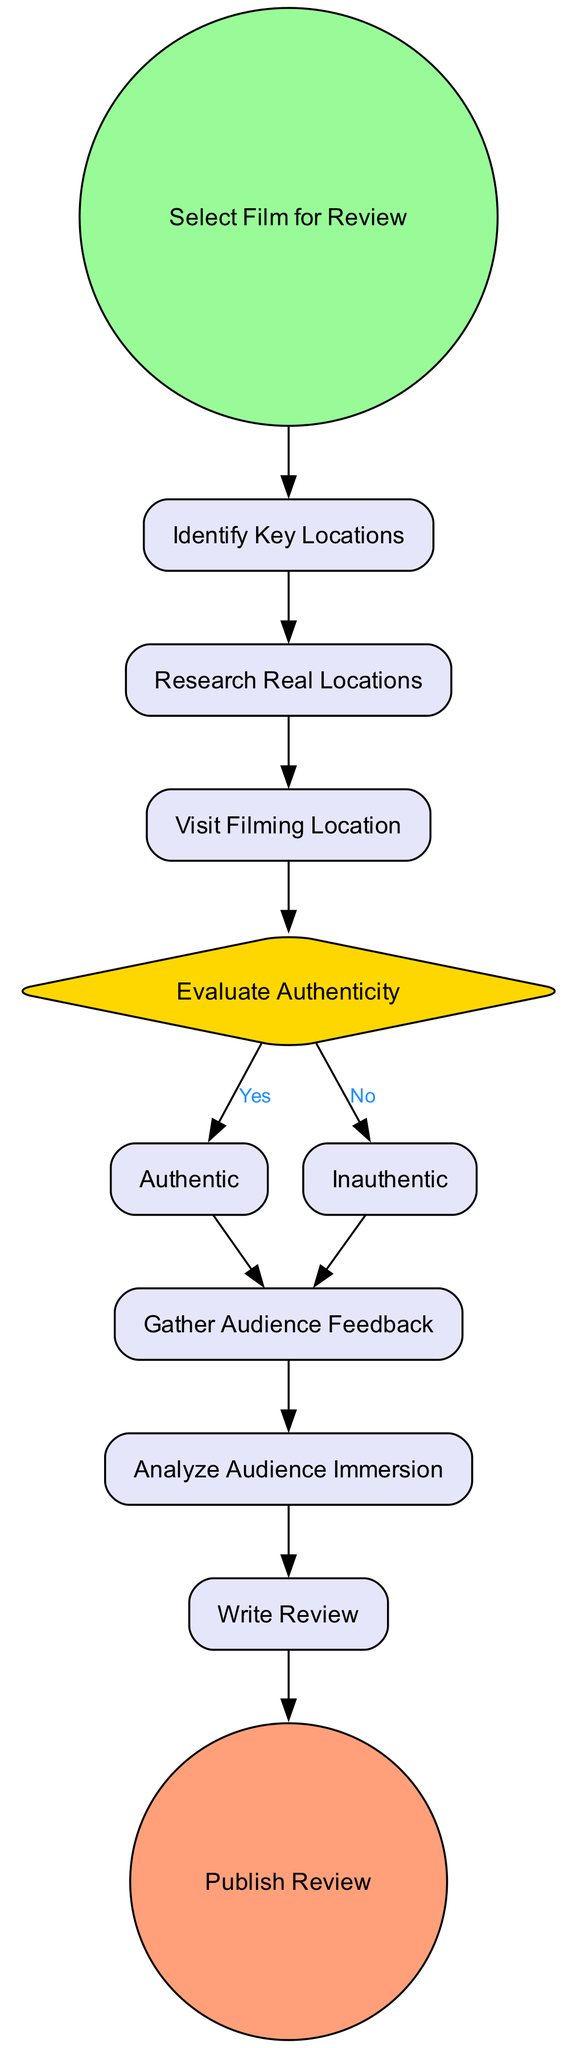What is the first activity in the diagram? The first activity is labeled as "Select Film for Review," indicating the starting point of the evaluation process.
Answer: Select Film for Review How many decision points are there in the diagram? There is one decision point labeled "Evaluate Authenticity," which dictates the flow based on whether the film location is authentic or inauthentic.
Answer: 1 What are the final activities before publishing the review? The final activities are "Write Review" and "Publish Review," which come sequentially after analyzing audience immersion.
Answer: Write Review, Publish Review If the decision is inauthentic, what is the next activity? If the decision is inauthentic, the next activity is "Gather Audience Feedback," which follows after the "Inauthentic" task.
Answer: Gather Audience Feedback What activity follows the "Visit Filming Location"? After "Visit Filming Location," the next activity is "Evaluate Authenticity," where the authenticity of the film locations is assessed.
Answer: Evaluate Authenticity How many tasks are present in the diagram? There are six tasks in the diagram, which include "Identify Key Locations," "Research Real Locations," "Visit Filming Location," "Gather Audience Feedback," "Analyze Audience Immersion," and "Write Review."
Answer: 6 What happens if the authenticity is evaluated as authentic? If the authenticity is evaluated as authentic, the process moves to "Gather Audience Feedback," which aims to collect audience responses regarding the film’s locations.
Answer: Gather Audience Feedback What is the purpose of the "Analyze Audience Immersion" task? The purpose of "Analyze Audience Immersion" is to examine how the authenticity of film locations affects the audience's engagement with the film.
Answer: Analyze Audience Immersion 